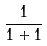<formula> <loc_0><loc_0><loc_500><loc_500>\frac { 1 } { 1 + 1 }</formula> 